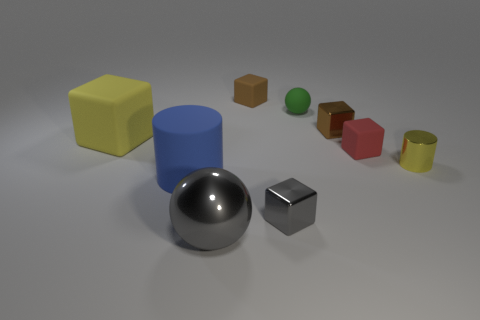What size is the rubber block that is the same color as the metallic cylinder?
Ensure brevity in your answer.  Large. How many tiny brown shiny objects are in front of the big thing that is left of the big matte object that is in front of the large matte block?
Offer a very short reply. 0. Is the metallic cylinder the same color as the large block?
Provide a succinct answer. Yes. Are there any rubber cubes that have the same color as the tiny metal cylinder?
Make the answer very short. Yes. There is a ball that is the same size as the yellow shiny cylinder; what color is it?
Your answer should be compact. Green. Is there a large yellow rubber thing that has the same shape as the tiny brown metallic object?
Ensure brevity in your answer.  Yes. There is a small object that is the same color as the big matte block; what shape is it?
Your response must be concise. Cylinder. Are there any green things that are in front of the tiny rubber cube that is in front of the metallic cube behind the tiny red rubber cube?
Provide a short and direct response. No. There is a brown matte thing that is the same size as the gray metallic block; what shape is it?
Offer a terse response. Cube. What color is the other thing that is the same shape as the big gray shiny object?
Keep it short and to the point. Green. 